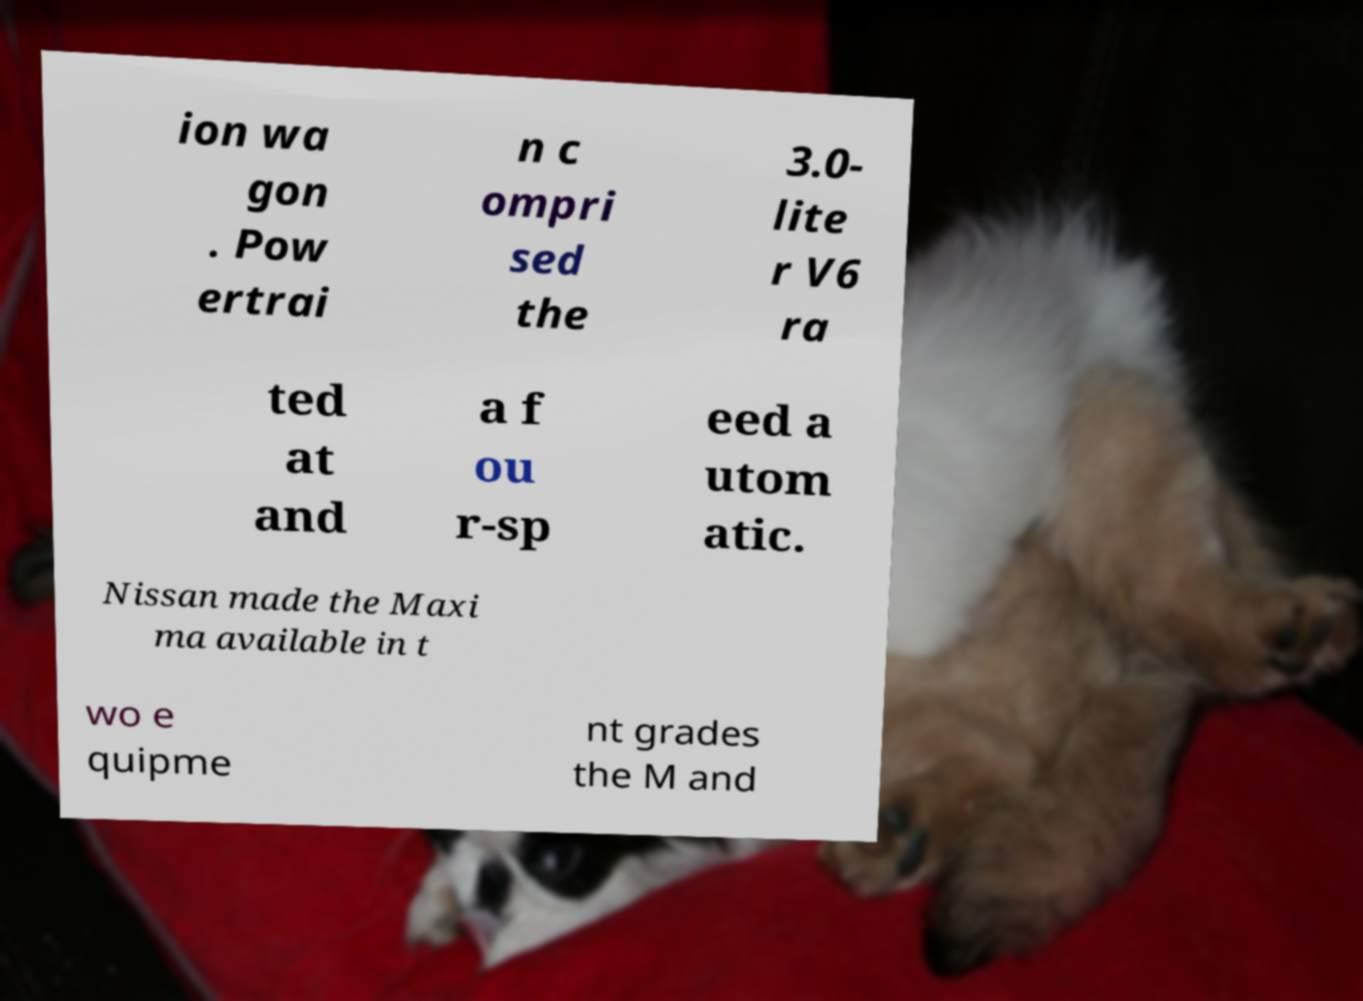Please read and relay the text visible in this image. What does it say? ion wa gon . Pow ertrai n c ompri sed the 3.0- lite r V6 ra ted at and a f ou r-sp eed a utom atic. Nissan made the Maxi ma available in t wo e quipme nt grades the M and 